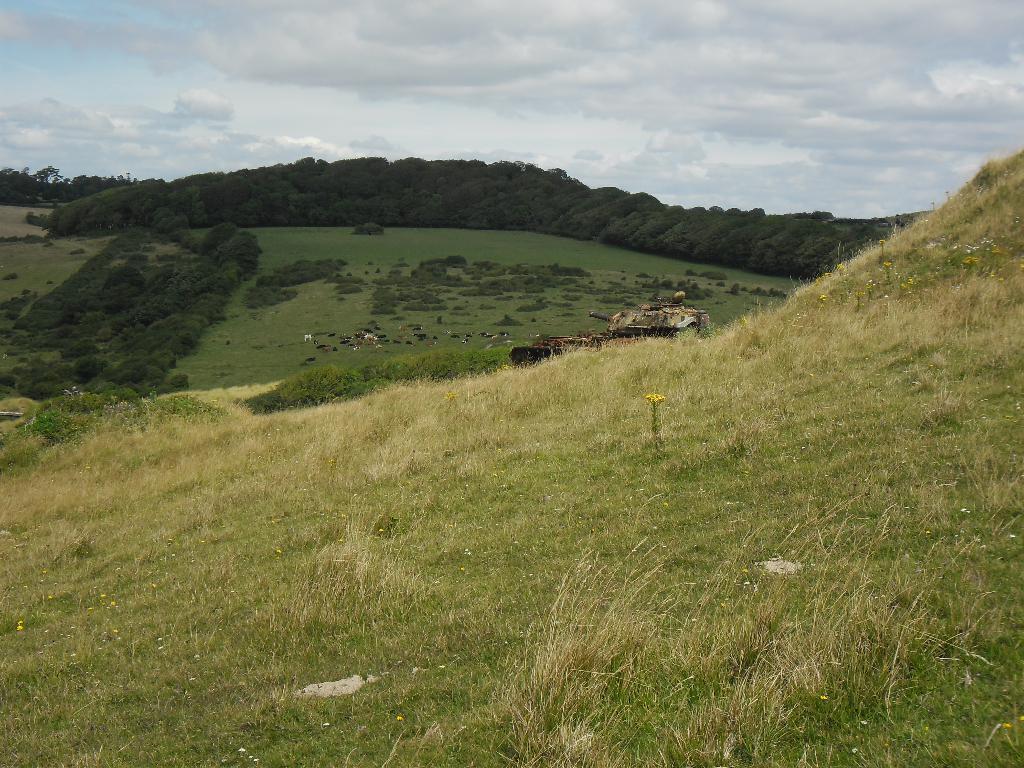Describe this image in one or two sentences. In this picture we can see grass at the bottom, in the background there are some trees, we can see animals here, there is the sky at the top of the picture. 